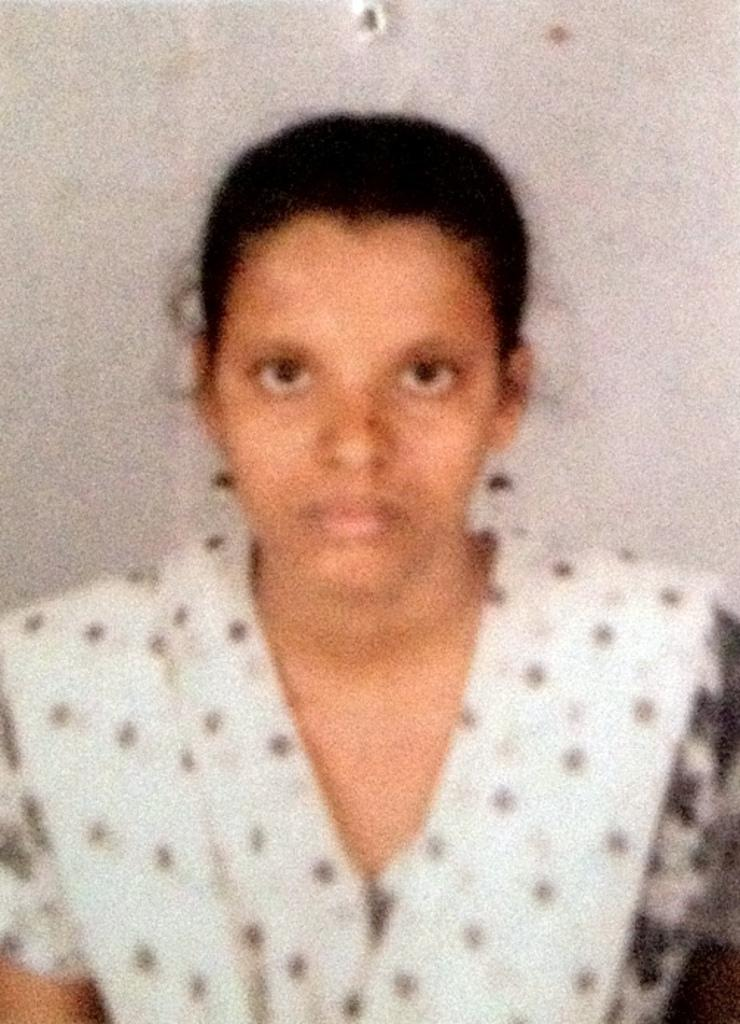Who is present in the image? There is a woman in the image. What can be seen in the background of the image? The background of the image is white. What type of book is the woman holding in the image? There is no book present in the image; only the woman and the white background are visible. 